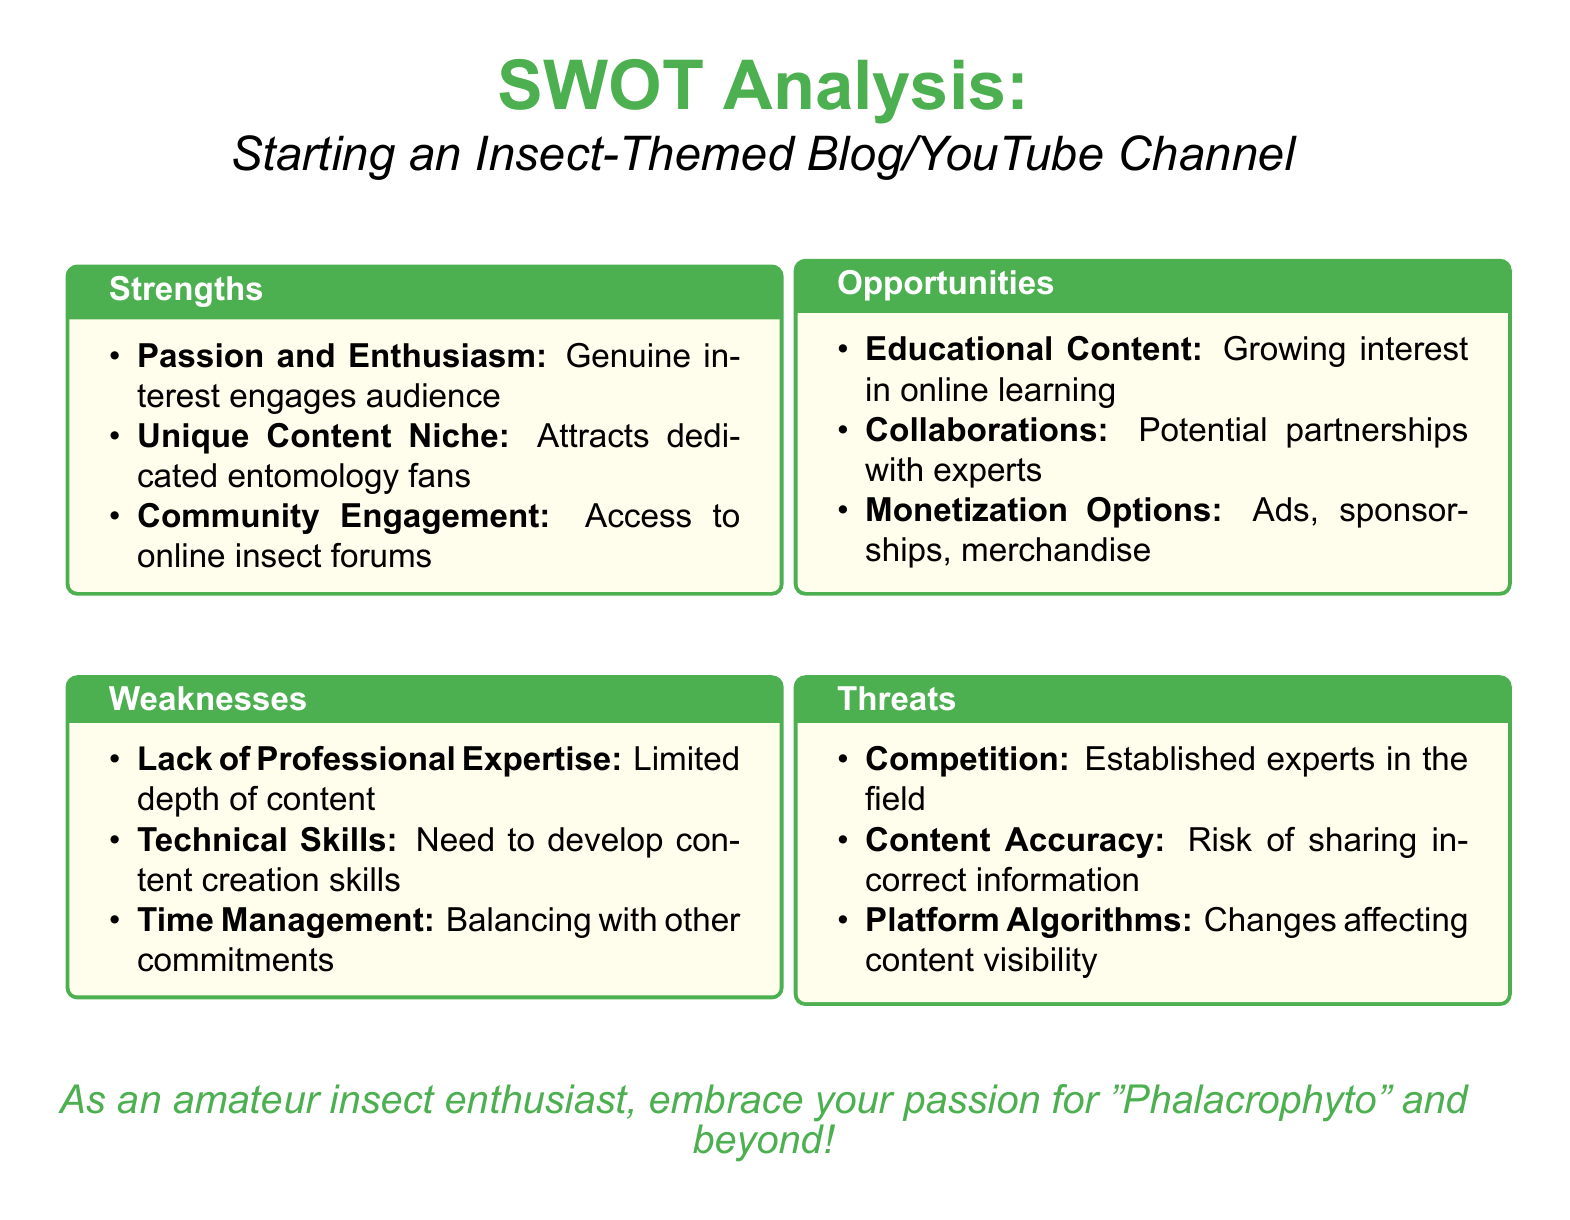What is the title of the document? The title is prominently featured at the top of the document, indicating the topic of the analysis.
Answer: SWOT Analysis: Starting an Insect-Themed Blog/YouTube Channel How many strengths are listed in the document? The number of strengths is determined by counting the items in the strengths section.
Answer: 3 What is one weakness mentioned in the document? Weaknesses are listed in a dedicated section, any one can be cited.
Answer: Lack of Professional Expertise What are two monetization options identified in the opportunities section? Opportunities include various options that can be capitalized on, including them listed in the document.
Answer: Ads, sponsorships What is a potential threat related to content accuracy? The threat section includes specific concerns that could arise when sharing information, among which accuracy stands out.
Answer: Risk of sharing incorrect information What type of content is mentioned as a growing interest? This refers to the trend noted in the opportunities section that could benefit from the proposed blog/channel.
Answer: Educational Content What color scheme is used in the document? The color scheme is described by the specific colors used for titles and boxes throughout the document.
Answer: Insect green and insect yellow 